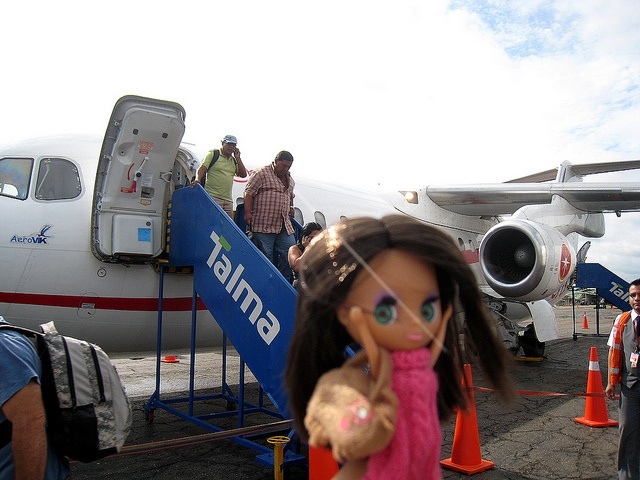Describe the objects in this image and their specific colors. I can see airplane in white, gray, darkgray, lightgray, and navy tones, backpack in white, black, and gray tones, handbag in white, brown, maroon, and tan tones, people in white, black, maroon, navy, and blue tones, and people in white, black, gray, and maroon tones in this image. 